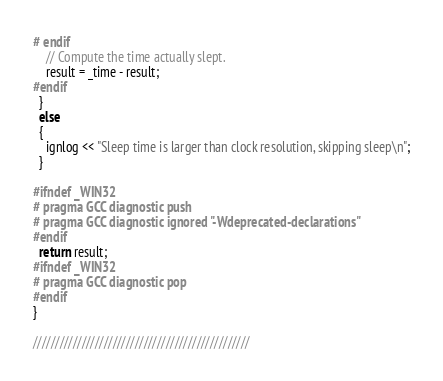Convert code to text. <code><loc_0><loc_0><loc_500><loc_500><_C++_># endif
    // Compute the time actually slept.
    result = _time - result;
#endif
  }
  else
  {
    ignlog << "Sleep time is larger than clock resolution, skipping sleep\n";
  }

#ifndef _WIN32
# pragma GCC diagnostic push
# pragma GCC diagnostic ignored "-Wdeprecated-declarations"
#endif
  return result;
#ifndef _WIN32
# pragma GCC diagnostic pop
#endif
}

/////////////////////////////////////////////////</code> 